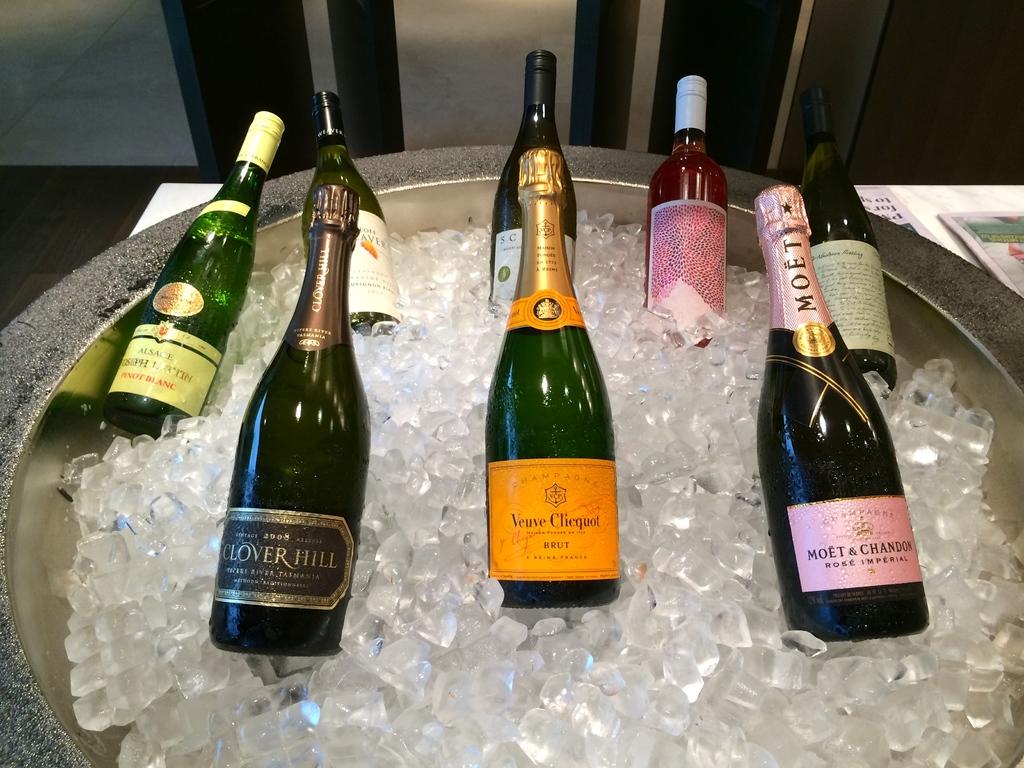What brand of wine is in the bottle on the bottom right?
Offer a terse response. Moet & chandon. 